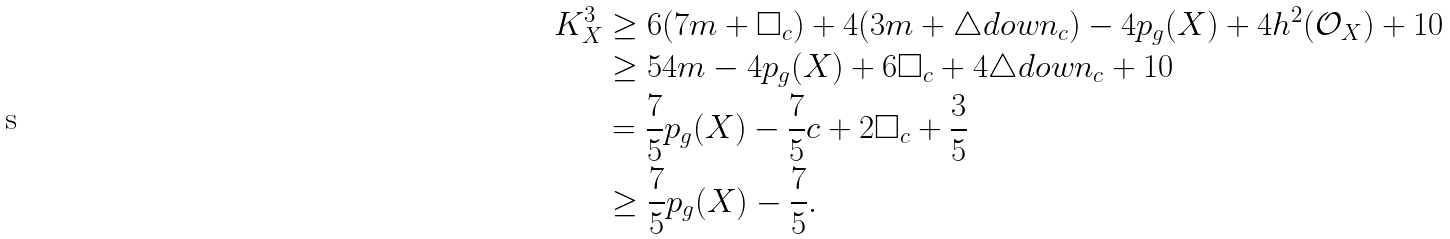Convert formula to latex. <formula><loc_0><loc_0><loc_500><loc_500>K _ { X } ^ { 3 } & \geq 6 ( 7 m + \Box _ { c } ) + 4 ( 3 m + \triangle d o w n _ { c } ) - 4 p _ { g } ( X ) + 4 h ^ { 2 } ( { \mathcal { O } } _ { X } ) + 1 0 \\ & \geq 5 4 m - 4 p _ { g } ( X ) + 6 \Box _ { c } + 4 \triangle d o w n _ { c } + 1 0 \\ & = \frac { 7 } { 5 } p _ { g } ( X ) - \frac { 7 } { 5 } c + 2 \Box _ { c } + \frac { 3 } { 5 } \\ & \geq \frac { 7 } { 5 } p _ { g } ( X ) - \frac { 7 } { 5 } .</formula> 